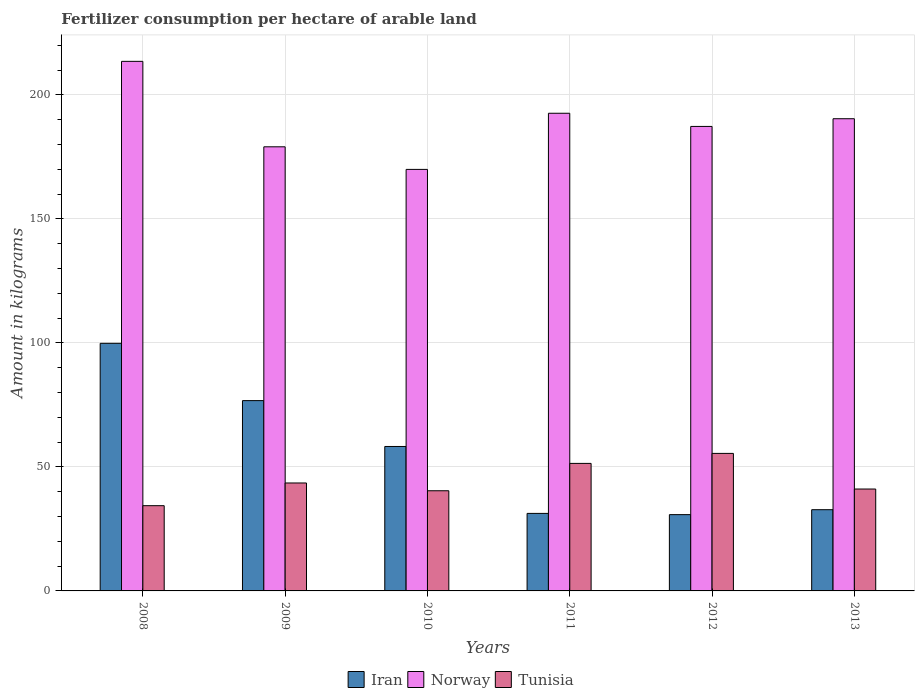Are the number of bars on each tick of the X-axis equal?
Offer a terse response. Yes. How many bars are there on the 4th tick from the left?
Your response must be concise. 3. How many bars are there on the 6th tick from the right?
Your answer should be compact. 3. In how many cases, is the number of bars for a given year not equal to the number of legend labels?
Your answer should be compact. 0. What is the amount of fertilizer consumption in Iran in 2008?
Offer a very short reply. 99.85. Across all years, what is the maximum amount of fertilizer consumption in Norway?
Your answer should be very brief. 213.56. Across all years, what is the minimum amount of fertilizer consumption in Tunisia?
Give a very brief answer. 34.38. In which year was the amount of fertilizer consumption in Tunisia minimum?
Give a very brief answer. 2008. What is the total amount of fertilizer consumption in Norway in the graph?
Your response must be concise. 1133. What is the difference between the amount of fertilizer consumption in Iran in 2008 and that in 2010?
Give a very brief answer. 41.6. What is the difference between the amount of fertilizer consumption in Iran in 2010 and the amount of fertilizer consumption in Norway in 2009?
Give a very brief answer. -120.85. What is the average amount of fertilizer consumption in Tunisia per year?
Make the answer very short. 44.38. In the year 2009, what is the difference between the amount of fertilizer consumption in Tunisia and amount of fertilizer consumption in Norway?
Your response must be concise. -135.57. What is the ratio of the amount of fertilizer consumption in Iran in 2011 to that in 2012?
Offer a very short reply. 1.02. Is the amount of fertilizer consumption in Iran in 2011 less than that in 2013?
Your answer should be compact. Yes. What is the difference between the highest and the second highest amount of fertilizer consumption in Iran?
Your answer should be very brief. 23.1. What is the difference between the highest and the lowest amount of fertilizer consumption in Norway?
Offer a terse response. 43.57. What does the 3rd bar from the left in 2012 represents?
Give a very brief answer. Tunisia. What does the 2nd bar from the right in 2012 represents?
Ensure brevity in your answer.  Norway. Is it the case that in every year, the sum of the amount of fertilizer consumption in Norway and amount of fertilizer consumption in Iran is greater than the amount of fertilizer consumption in Tunisia?
Offer a terse response. Yes. Are all the bars in the graph horizontal?
Ensure brevity in your answer.  No. How many legend labels are there?
Give a very brief answer. 3. How are the legend labels stacked?
Provide a short and direct response. Horizontal. What is the title of the graph?
Provide a short and direct response. Fertilizer consumption per hectare of arable land. What is the label or title of the X-axis?
Give a very brief answer. Years. What is the label or title of the Y-axis?
Your answer should be very brief. Amount in kilograms. What is the Amount in kilograms of Iran in 2008?
Offer a terse response. 99.85. What is the Amount in kilograms of Norway in 2008?
Make the answer very short. 213.56. What is the Amount in kilograms in Tunisia in 2008?
Make the answer very short. 34.38. What is the Amount in kilograms in Iran in 2009?
Keep it short and to the point. 76.74. What is the Amount in kilograms of Norway in 2009?
Ensure brevity in your answer.  179.1. What is the Amount in kilograms in Tunisia in 2009?
Give a very brief answer. 43.53. What is the Amount in kilograms in Iran in 2010?
Make the answer very short. 58.25. What is the Amount in kilograms of Norway in 2010?
Ensure brevity in your answer.  169.98. What is the Amount in kilograms of Tunisia in 2010?
Offer a terse response. 40.4. What is the Amount in kilograms of Iran in 2011?
Keep it short and to the point. 31.26. What is the Amount in kilograms in Norway in 2011?
Ensure brevity in your answer.  192.63. What is the Amount in kilograms in Tunisia in 2011?
Ensure brevity in your answer.  51.42. What is the Amount in kilograms in Iran in 2012?
Ensure brevity in your answer.  30.76. What is the Amount in kilograms in Norway in 2012?
Provide a short and direct response. 187.32. What is the Amount in kilograms of Tunisia in 2012?
Keep it short and to the point. 55.46. What is the Amount in kilograms in Iran in 2013?
Ensure brevity in your answer.  32.75. What is the Amount in kilograms in Norway in 2013?
Offer a very short reply. 190.42. What is the Amount in kilograms in Tunisia in 2013?
Give a very brief answer. 41.09. Across all years, what is the maximum Amount in kilograms in Iran?
Offer a terse response. 99.85. Across all years, what is the maximum Amount in kilograms of Norway?
Provide a succinct answer. 213.56. Across all years, what is the maximum Amount in kilograms in Tunisia?
Give a very brief answer. 55.46. Across all years, what is the minimum Amount in kilograms of Iran?
Keep it short and to the point. 30.76. Across all years, what is the minimum Amount in kilograms in Norway?
Provide a succinct answer. 169.98. Across all years, what is the minimum Amount in kilograms of Tunisia?
Your response must be concise. 34.38. What is the total Amount in kilograms in Iran in the graph?
Your answer should be very brief. 329.62. What is the total Amount in kilograms in Norway in the graph?
Make the answer very short. 1133. What is the total Amount in kilograms in Tunisia in the graph?
Your response must be concise. 266.27. What is the difference between the Amount in kilograms of Iran in 2008 and that in 2009?
Your response must be concise. 23.1. What is the difference between the Amount in kilograms in Norway in 2008 and that in 2009?
Give a very brief answer. 34.46. What is the difference between the Amount in kilograms in Tunisia in 2008 and that in 2009?
Offer a terse response. -9.15. What is the difference between the Amount in kilograms of Iran in 2008 and that in 2010?
Ensure brevity in your answer.  41.6. What is the difference between the Amount in kilograms of Norway in 2008 and that in 2010?
Make the answer very short. 43.57. What is the difference between the Amount in kilograms of Tunisia in 2008 and that in 2010?
Your answer should be compact. -6.02. What is the difference between the Amount in kilograms of Iran in 2008 and that in 2011?
Your answer should be very brief. 68.59. What is the difference between the Amount in kilograms of Norway in 2008 and that in 2011?
Your answer should be compact. 20.93. What is the difference between the Amount in kilograms in Tunisia in 2008 and that in 2011?
Provide a short and direct response. -17.05. What is the difference between the Amount in kilograms in Iran in 2008 and that in 2012?
Give a very brief answer. 69.08. What is the difference between the Amount in kilograms of Norway in 2008 and that in 2012?
Provide a short and direct response. 26.24. What is the difference between the Amount in kilograms in Tunisia in 2008 and that in 2012?
Give a very brief answer. -21.08. What is the difference between the Amount in kilograms of Iran in 2008 and that in 2013?
Provide a succinct answer. 67.09. What is the difference between the Amount in kilograms of Norway in 2008 and that in 2013?
Your answer should be compact. 23.14. What is the difference between the Amount in kilograms of Tunisia in 2008 and that in 2013?
Your answer should be very brief. -6.72. What is the difference between the Amount in kilograms of Iran in 2009 and that in 2010?
Make the answer very short. 18.49. What is the difference between the Amount in kilograms of Norway in 2009 and that in 2010?
Provide a succinct answer. 9.12. What is the difference between the Amount in kilograms of Tunisia in 2009 and that in 2010?
Make the answer very short. 3.13. What is the difference between the Amount in kilograms of Iran in 2009 and that in 2011?
Make the answer very short. 45.48. What is the difference between the Amount in kilograms in Norway in 2009 and that in 2011?
Your response must be concise. -13.53. What is the difference between the Amount in kilograms of Tunisia in 2009 and that in 2011?
Your answer should be compact. -7.9. What is the difference between the Amount in kilograms in Iran in 2009 and that in 2012?
Provide a short and direct response. 45.98. What is the difference between the Amount in kilograms in Norway in 2009 and that in 2012?
Give a very brief answer. -8.22. What is the difference between the Amount in kilograms of Tunisia in 2009 and that in 2012?
Offer a very short reply. -11.93. What is the difference between the Amount in kilograms of Iran in 2009 and that in 2013?
Give a very brief answer. 43.99. What is the difference between the Amount in kilograms in Norway in 2009 and that in 2013?
Offer a very short reply. -11.32. What is the difference between the Amount in kilograms in Tunisia in 2009 and that in 2013?
Provide a short and direct response. 2.44. What is the difference between the Amount in kilograms in Iran in 2010 and that in 2011?
Make the answer very short. 26.99. What is the difference between the Amount in kilograms of Norway in 2010 and that in 2011?
Offer a terse response. -22.64. What is the difference between the Amount in kilograms in Tunisia in 2010 and that in 2011?
Your response must be concise. -11.03. What is the difference between the Amount in kilograms in Iran in 2010 and that in 2012?
Your answer should be compact. 27.49. What is the difference between the Amount in kilograms in Norway in 2010 and that in 2012?
Give a very brief answer. -17.33. What is the difference between the Amount in kilograms in Tunisia in 2010 and that in 2012?
Ensure brevity in your answer.  -15.06. What is the difference between the Amount in kilograms of Iran in 2010 and that in 2013?
Ensure brevity in your answer.  25.5. What is the difference between the Amount in kilograms in Norway in 2010 and that in 2013?
Keep it short and to the point. -20.43. What is the difference between the Amount in kilograms of Tunisia in 2010 and that in 2013?
Your response must be concise. -0.7. What is the difference between the Amount in kilograms of Iran in 2011 and that in 2012?
Make the answer very short. 0.5. What is the difference between the Amount in kilograms in Norway in 2011 and that in 2012?
Make the answer very short. 5.31. What is the difference between the Amount in kilograms of Tunisia in 2011 and that in 2012?
Offer a very short reply. -4.03. What is the difference between the Amount in kilograms of Iran in 2011 and that in 2013?
Your response must be concise. -1.49. What is the difference between the Amount in kilograms of Norway in 2011 and that in 2013?
Provide a succinct answer. 2.21. What is the difference between the Amount in kilograms of Tunisia in 2011 and that in 2013?
Your response must be concise. 10.33. What is the difference between the Amount in kilograms in Iran in 2012 and that in 2013?
Give a very brief answer. -1.99. What is the difference between the Amount in kilograms in Norway in 2012 and that in 2013?
Your response must be concise. -3.1. What is the difference between the Amount in kilograms of Tunisia in 2012 and that in 2013?
Your answer should be very brief. 14.36. What is the difference between the Amount in kilograms in Iran in 2008 and the Amount in kilograms in Norway in 2009?
Ensure brevity in your answer.  -79.25. What is the difference between the Amount in kilograms of Iran in 2008 and the Amount in kilograms of Tunisia in 2009?
Offer a terse response. 56.32. What is the difference between the Amount in kilograms of Norway in 2008 and the Amount in kilograms of Tunisia in 2009?
Offer a terse response. 170.03. What is the difference between the Amount in kilograms of Iran in 2008 and the Amount in kilograms of Norway in 2010?
Provide a succinct answer. -70.14. What is the difference between the Amount in kilograms in Iran in 2008 and the Amount in kilograms in Tunisia in 2010?
Offer a terse response. 59.45. What is the difference between the Amount in kilograms of Norway in 2008 and the Amount in kilograms of Tunisia in 2010?
Your response must be concise. 173.16. What is the difference between the Amount in kilograms in Iran in 2008 and the Amount in kilograms in Norway in 2011?
Provide a succinct answer. -92.78. What is the difference between the Amount in kilograms of Iran in 2008 and the Amount in kilograms of Tunisia in 2011?
Your answer should be compact. 48.42. What is the difference between the Amount in kilograms in Norway in 2008 and the Amount in kilograms in Tunisia in 2011?
Offer a very short reply. 162.13. What is the difference between the Amount in kilograms in Iran in 2008 and the Amount in kilograms in Norway in 2012?
Your answer should be very brief. -87.47. What is the difference between the Amount in kilograms in Iran in 2008 and the Amount in kilograms in Tunisia in 2012?
Give a very brief answer. 44.39. What is the difference between the Amount in kilograms in Norway in 2008 and the Amount in kilograms in Tunisia in 2012?
Provide a succinct answer. 158.1. What is the difference between the Amount in kilograms of Iran in 2008 and the Amount in kilograms of Norway in 2013?
Ensure brevity in your answer.  -90.57. What is the difference between the Amount in kilograms in Iran in 2008 and the Amount in kilograms in Tunisia in 2013?
Provide a succinct answer. 58.76. What is the difference between the Amount in kilograms in Norway in 2008 and the Amount in kilograms in Tunisia in 2013?
Your response must be concise. 172.47. What is the difference between the Amount in kilograms of Iran in 2009 and the Amount in kilograms of Norway in 2010?
Keep it short and to the point. -93.24. What is the difference between the Amount in kilograms of Iran in 2009 and the Amount in kilograms of Tunisia in 2010?
Your answer should be very brief. 36.35. What is the difference between the Amount in kilograms of Norway in 2009 and the Amount in kilograms of Tunisia in 2010?
Ensure brevity in your answer.  138.7. What is the difference between the Amount in kilograms of Iran in 2009 and the Amount in kilograms of Norway in 2011?
Provide a succinct answer. -115.88. What is the difference between the Amount in kilograms in Iran in 2009 and the Amount in kilograms in Tunisia in 2011?
Your answer should be very brief. 25.32. What is the difference between the Amount in kilograms of Norway in 2009 and the Amount in kilograms of Tunisia in 2011?
Give a very brief answer. 127.68. What is the difference between the Amount in kilograms in Iran in 2009 and the Amount in kilograms in Norway in 2012?
Offer a very short reply. -110.57. What is the difference between the Amount in kilograms of Iran in 2009 and the Amount in kilograms of Tunisia in 2012?
Make the answer very short. 21.29. What is the difference between the Amount in kilograms of Norway in 2009 and the Amount in kilograms of Tunisia in 2012?
Your answer should be very brief. 123.64. What is the difference between the Amount in kilograms of Iran in 2009 and the Amount in kilograms of Norway in 2013?
Offer a very short reply. -113.67. What is the difference between the Amount in kilograms in Iran in 2009 and the Amount in kilograms in Tunisia in 2013?
Offer a very short reply. 35.65. What is the difference between the Amount in kilograms in Norway in 2009 and the Amount in kilograms in Tunisia in 2013?
Keep it short and to the point. 138.01. What is the difference between the Amount in kilograms in Iran in 2010 and the Amount in kilograms in Norway in 2011?
Ensure brevity in your answer.  -134.38. What is the difference between the Amount in kilograms in Iran in 2010 and the Amount in kilograms in Tunisia in 2011?
Offer a terse response. 6.83. What is the difference between the Amount in kilograms in Norway in 2010 and the Amount in kilograms in Tunisia in 2011?
Offer a very short reply. 118.56. What is the difference between the Amount in kilograms in Iran in 2010 and the Amount in kilograms in Norway in 2012?
Offer a terse response. -129.07. What is the difference between the Amount in kilograms in Iran in 2010 and the Amount in kilograms in Tunisia in 2012?
Your answer should be compact. 2.79. What is the difference between the Amount in kilograms in Norway in 2010 and the Amount in kilograms in Tunisia in 2012?
Your answer should be compact. 114.53. What is the difference between the Amount in kilograms of Iran in 2010 and the Amount in kilograms of Norway in 2013?
Your answer should be compact. -132.17. What is the difference between the Amount in kilograms in Iran in 2010 and the Amount in kilograms in Tunisia in 2013?
Give a very brief answer. 17.16. What is the difference between the Amount in kilograms of Norway in 2010 and the Amount in kilograms of Tunisia in 2013?
Your answer should be compact. 128.89. What is the difference between the Amount in kilograms of Iran in 2011 and the Amount in kilograms of Norway in 2012?
Offer a terse response. -156.06. What is the difference between the Amount in kilograms in Iran in 2011 and the Amount in kilograms in Tunisia in 2012?
Give a very brief answer. -24.2. What is the difference between the Amount in kilograms of Norway in 2011 and the Amount in kilograms of Tunisia in 2012?
Your answer should be very brief. 137.17. What is the difference between the Amount in kilograms in Iran in 2011 and the Amount in kilograms in Norway in 2013?
Your response must be concise. -159.16. What is the difference between the Amount in kilograms in Iran in 2011 and the Amount in kilograms in Tunisia in 2013?
Offer a very short reply. -9.83. What is the difference between the Amount in kilograms of Norway in 2011 and the Amount in kilograms of Tunisia in 2013?
Make the answer very short. 151.54. What is the difference between the Amount in kilograms in Iran in 2012 and the Amount in kilograms in Norway in 2013?
Your answer should be very brief. -159.66. What is the difference between the Amount in kilograms in Iran in 2012 and the Amount in kilograms in Tunisia in 2013?
Make the answer very short. -10.33. What is the difference between the Amount in kilograms in Norway in 2012 and the Amount in kilograms in Tunisia in 2013?
Give a very brief answer. 146.22. What is the average Amount in kilograms of Iran per year?
Your response must be concise. 54.94. What is the average Amount in kilograms in Norway per year?
Your answer should be very brief. 188.83. What is the average Amount in kilograms in Tunisia per year?
Offer a terse response. 44.38. In the year 2008, what is the difference between the Amount in kilograms of Iran and Amount in kilograms of Norway?
Ensure brevity in your answer.  -113.71. In the year 2008, what is the difference between the Amount in kilograms of Iran and Amount in kilograms of Tunisia?
Ensure brevity in your answer.  65.47. In the year 2008, what is the difference between the Amount in kilograms of Norway and Amount in kilograms of Tunisia?
Provide a succinct answer. 179.18. In the year 2009, what is the difference between the Amount in kilograms of Iran and Amount in kilograms of Norway?
Make the answer very short. -102.36. In the year 2009, what is the difference between the Amount in kilograms of Iran and Amount in kilograms of Tunisia?
Your response must be concise. 33.22. In the year 2009, what is the difference between the Amount in kilograms of Norway and Amount in kilograms of Tunisia?
Your response must be concise. 135.57. In the year 2010, what is the difference between the Amount in kilograms in Iran and Amount in kilograms in Norway?
Ensure brevity in your answer.  -111.73. In the year 2010, what is the difference between the Amount in kilograms in Iran and Amount in kilograms in Tunisia?
Offer a terse response. 17.85. In the year 2010, what is the difference between the Amount in kilograms of Norway and Amount in kilograms of Tunisia?
Keep it short and to the point. 129.59. In the year 2011, what is the difference between the Amount in kilograms in Iran and Amount in kilograms in Norway?
Provide a succinct answer. -161.37. In the year 2011, what is the difference between the Amount in kilograms of Iran and Amount in kilograms of Tunisia?
Offer a terse response. -20.16. In the year 2011, what is the difference between the Amount in kilograms in Norway and Amount in kilograms in Tunisia?
Your answer should be very brief. 141.2. In the year 2012, what is the difference between the Amount in kilograms in Iran and Amount in kilograms in Norway?
Provide a short and direct response. -156.55. In the year 2012, what is the difference between the Amount in kilograms of Iran and Amount in kilograms of Tunisia?
Your response must be concise. -24.69. In the year 2012, what is the difference between the Amount in kilograms in Norway and Amount in kilograms in Tunisia?
Your answer should be very brief. 131.86. In the year 2013, what is the difference between the Amount in kilograms in Iran and Amount in kilograms in Norway?
Your response must be concise. -157.67. In the year 2013, what is the difference between the Amount in kilograms of Iran and Amount in kilograms of Tunisia?
Give a very brief answer. -8.34. In the year 2013, what is the difference between the Amount in kilograms in Norway and Amount in kilograms in Tunisia?
Make the answer very short. 149.33. What is the ratio of the Amount in kilograms of Iran in 2008 to that in 2009?
Offer a terse response. 1.3. What is the ratio of the Amount in kilograms in Norway in 2008 to that in 2009?
Give a very brief answer. 1.19. What is the ratio of the Amount in kilograms of Tunisia in 2008 to that in 2009?
Ensure brevity in your answer.  0.79. What is the ratio of the Amount in kilograms in Iran in 2008 to that in 2010?
Your answer should be very brief. 1.71. What is the ratio of the Amount in kilograms of Norway in 2008 to that in 2010?
Your answer should be compact. 1.26. What is the ratio of the Amount in kilograms of Tunisia in 2008 to that in 2010?
Your answer should be very brief. 0.85. What is the ratio of the Amount in kilograms in Iran in 2008 to that in 2011?
Give a very brief answer. 3.19. What is the ratio of the Amount in kilograms in Norway in 2008 to that in 2011?
Give a very brief answer. 1.11. What is the ratio of the Amount in kilograms in Tunisia in 2008 to that in 2011?
Provide a short and direct response. 0.67. What is the ratio of the Amount in kilograms of Iran in 2008 to that in 2012?
Keep it short and to the point. 3.25. What is the ratio of the Amount in kilograms in Norway in 2008 to that in 2012?
Ensure brevity in your answer.  1.14. What is the ratio of the Amount in kilograms in Tunisia in 2008 to that in 2012?
Ensure brevity in your answer.  0.62. What is the ratio of the Amount in kilograms of Iran in 2008 to that in 2013?
Your answer should be very brief. 3.05. What is the ratio of the Amount in kilograms of Norway in 2008 to that in 2013?
Offer a terse response. 1.12. What is the ratio of the Amount in kilograms of Tunisia in 2008 to that in 2013?
Offer a very short reply. 0.84. What is the ratio of the Amount in kilograms in Iran in 2009 to that in 2010?
Keep it short and to the point. 1.32. What is the ratio of the Amount in kilograms of Norway in 2009 to that in 2010?
Make the answer very short. 1.05. What is the ratio of the Amount in kilograms in Tunisia in 2009 to that in 2010?
Make the answer very short. 1.08. What is the ratio of the Amount in kilograms in Iran in 2009 to that in 2011?
Ensure brevity in your answer.  2.46. What is the ratio of the Amount in kilograms of Norway in 2009 to that in 2011?
Keep it short and to the point. 0.93. What is the ratio of the Amount in kilograms in Tunisia in 2009 to that in 2011?
Keep it short and to the point. 0.85. What is the ratio of the Amount in kilograms of Iran in 2009 to that in 2012?
Ensure brevity in your answer.  2.49. What is the ratio of the Amount in kilograms of Norway in 2009 to that in 2012?
Provide a succinct answer. 0.96. What is the ratio of the Amount in kilograms of Tunisia in 2009 to that in 2012?
Offer a terse response. 0.78. What is the ratio of the Amount in kilograms of Iran in 2009 to that in 2013?
Offer a very short reply. 2.34. What is the ratio of the Amount in kilograms in Norway in 2009 to that in 2013?
Offer a very short reply. 0.94. What is the ratio of the Amount in kilograms of Tunisia in 2009 to that in 2013?
Offer a terse response. 1.06. What is the ratio of the Amount in kilograms in Iran in 2010 to that in 2011?
Offer a very short reply. 1.86. What is the ratio of the Amount in kilograms of Norway in 2010 to that in 2011?
Make the answer very short. 0.88. What is the ratio of the Amount in kilograms of Tunisia in 2010 to that in 2011?
Make the answer very short. 0.79. What is the ratio of the Amount in kilograms in Iran in 2010 to that in 2012?
Provide a short and direct response. 1.89. What is the ratio of the Amount in kilograms in Norway in 2010 to that in 2012?
Provide a short and direct response. 0.91. What is the ratio of the Amount in kilograms in Tunisia in 2010 to that in 2012?
Provide a succinct answer. 0.73. What is the ratio of the Amount in kilograms in Iran in 2010 to that in 2013?
Give a very brief answer. 1.78. What is the ratio of the Amount in kilograms in Norway in 2010 to that in 2013?
Provide a succinct answer. 0.89. What is the ratio of the Amount in kilograms of Tunisia in 2010 to that in 2013?
Provide a succinct answer. 0.98. What is the ratio of the Amount in kilograms of Iran in 2011 to that in 2012?
Keep it short and to the point. 1.02. What is the ratio of the Amount in kilograms in Norway in 2011 to that in 2012?
Provide a succinct answer. 1.03. What is the ratio of the Amount in kilograms of Tunisia in 2011 to that in 2012?
Give a very brief answer. 0.93. What is the ratio of the Amount in kilograms in Iran in 2011 to that in 2013?
Offer a terse response. 0.95. What is the ratio of the Amount in kilograms of Norway in 2011 to that in 2013?
Provide a short and direct response. 1.01. What is the ratio of the Amount in kilograms of Tunisia in 2011 to that in 2013?
Your response must be concise. 1.25. What is the ratio of the Amount in kilograms in Iran in 2012 to that in 2013?
Provide a succinct answer. 0.94. What is the ratio of the Amount in kilograms of Norway in 2012 to that in 2013?
Your answer should be very brief. 0.98. What is the ratio of the Amount in kilograms of Tunisia in 2012 to that in 2013?
Give a very brief answer. 1.35. What is the difference between the highest and the second highest Amount in kilograms of Iran?
Your answer should be compact. 23.1. What is the difference between the highest and the second highest Amount in kilograms in Norway?
Your response must be concise. 20.93. What is the difference between the highest and the second highest Amount in kilograms in Tunisia?
Offer a very short reply. 4.03. What is the difference between the highest and the lowest Amount in kilograms of Iran?
Provide a succinct answer. 69.08. What is the difference between the highest and the lowest Amount in kilograms of Norway?
Your answer should be very brief. 43.57. What is the difference between the highest and the lowest Amount in kilograms of Tunisia?
Keep it short and to the point. 21.08. 